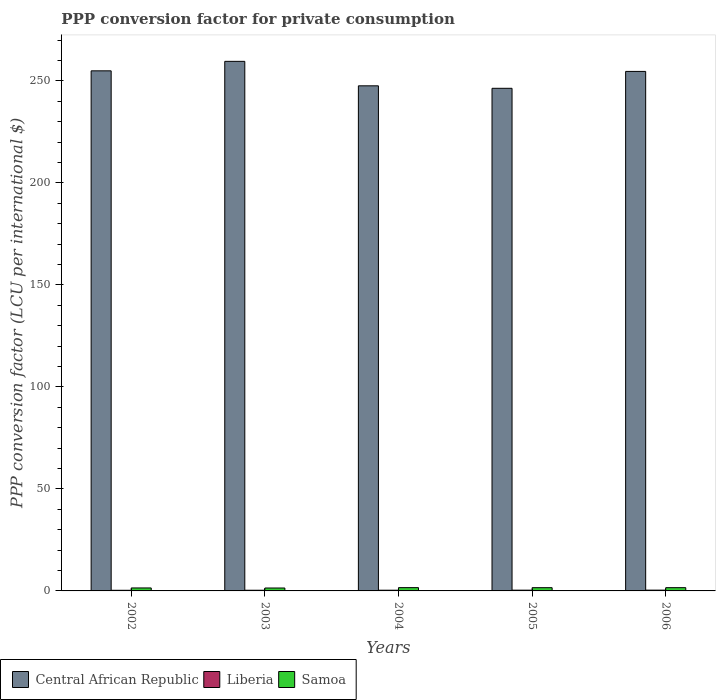How many different coloured bars are there?
Keep it short and to the point. 3. How many bars are there on the 1st tick from the right?
Give a very brief answer. 3. What is the label of the 1st group of bars from the left?
Your answer should be very brief. 2002. What is the PPP conversion factor for private consumption in Central African Republic in 2002?
Offer a terse response. 254.92. Across all years, what is the maximum PPP conversion factor for private consumption in Central African Republic?
Provide a succinct answer. 259.57. Across all years, what is the minimum PPP conversion factor for private consumption in Liberia?
Keep it short and to the point. 0.31. In which year was the PPP conversion factor for private consumption in Samoa maximum?
Your answer should be very brief. 2004. In which year was the PPP conversion factor for private consumption in Liberia minimum?
Offer a terse response. 2002. What is the total PPP conversion factor for private consumption in Liberia in the graph?
Offer a terse response. 1.74. What is the difference between the PPP conversion factor for private consumption in Central African Republic in 2002 and that in 2004?
Provide a short and direct response. 7.34. What is the difference between the PPP conversion factor for private consumption in Liberia in 2003 and the PPP conversion factor for private consumption in Samoa in 2005?
Ensure brevity in your answer.  -1.26. What is the average PPP conversion factor for private consumption in Central African Republic per year?
Give a very brief answer. 252.61. In the year 2006, what is the difference between the PPP conversion factor for private consumption in Central African Republic and PPP conversion factor for private consumption in Liberia?
Your answer should be compact. 254.25. What is the ratio of the PPP conversion factor for private consumption in Central African Republic in 2003 to that in 2004?
Ensure brevity in your answer.  1.05. What is the difference between the highest and the second highest PPP conversion factor for private consumption in Central African Republic?
Your answer should be very brief. 4.65. What is the difference between the highest and the lowest PPP conversion factor for private consumption in Liberia?
Give a very brief answer. 0.08. In how many years, is the PPP conversion factor for private consumption in Central African Republic greater than the average PPP conversion factor for private consumption in Central African Republic taken over all years?
Provide a succinct answer. 3. Is the sum of the PPP conversion factor for private consumption in Central African Republic in 2003 and 2004 greater than the maximum PPP conversion factor for private consumption in Samoa across all years?
Offer a terse response. Yes. What does the 1st bar from the left in 2004 represents?
Provide a succinct answer. Central African Republic. What does the 1st bar from the right in 2005 represents?
Keep it short and to the point. Samoa. Is it the case that in every year, the sum of the PPP conversion factor for private consumption in Samoa and PPP conversion factor for private consumption in Central African Republic is greater than the PPP conversion factor for private consumption in Liberia?
Your response must be concise. Yes. How many years are there in the graph?
Your answer should be very brief. 5. What is the difference between two consecutive major ticks on the Y-axis?
Your answer should be compact. 50. Are the values on the major ticks of Y-axis written in scientific E-notation?
Keep it short and to the point. No. Does the graph contain any zero values?
Offer a very short reply. No. Does the graph contain grids?
Give a very brief answer. No. Where does the legend appear in the graph?
Give a very brief answer. Bottom left. What is the title of the graph?
Provide a short and direct response. PPP conversion factor for private consumption. What is the label or title of the Y-axis?
Offer a terse response. PPP conversion factor (LCU per international $). What is the PPP conversion factor (LCU per international $) in Central African Republic in 2002?
Your answer should be compact. 254.92. What is the PPP conversion factor (LCU per international $) of Liberia in 2002?
Your answer should be compact. 0.31. What is the PPP conversion factor (LCU per international $) of Samoa in 2002?
Ensure brevity in your answer.  1.46. What is the PPP conversion factor (LCU per international $) in Central African Republic in 2003?
Ensure brevity in your answer.  259.57. What is the PPP conversion factor (LCU per international $) in Liberia in 2003?
Your response must be concise. 0.33. What is the PPP conversion factor (LCU per international $) of Samoa in 2003?
Keep it short and to the point. 1.42. What is the PPP conversion factor (LCU per international $) in Central African Republic in 2004?
Ensure brevity in your answer.  247.57. What is the PPP conversion factor (LCU per international $) of Liberia in 2004?
Your answer should be very brief. 0.35. What is the PPP conversion factor (LCU per international $) of Samoa in 2004?
Provide a succinct answer. 1.61. What is the PPP conversion factor (LCU per international $) of Central African Republic in 2005?
Keep it short and to the point. 246.35. What is the PPP conversion factor (LCU per international $) of Liberia in 2005?
Offer a terse response. 0.37. What is the PPP conversion factor (LCU per international $) of Samoa in 2005?
Provide a succinct answer. 1.59. What is the PPP conversion factor (LCU per international $) of Central African Republic in 2006?
Your answer should be very brief. 254.63. What is the PPP conversion factor (LCU per international $) of Liberia in 2006?
Your answer should be very brief. 0.39. What is the PPP conversion factor (LCU per international $) of Samoa in 2006?
Offer a very short reply. 1.6. Across all years, what is the maximum PPP conversion factor (LCU per international $) in Central African Republic?
Your response must be concise. 259.57. Across all years, what is the maximum PPP conversion factor (LCU per international $) of Liberia?
Offer a very short reply. 0.39. Across all years, what is the maximum PPP conversion factor (LCU per international $) of Samoa?
Ensure brevity in your answer.  1.61. Across all years, what is the minimum PPP conversion factor (LCU per international $) in Central African Republic?
Make the answer very short. 246.35. Across all years, what is the minimum PPP conversion factor (LCU per international $) of Liberia?
Offer a terse response. 0.31. Across all years, what is the minimum PPP conversion factor (LCU per international $) in Samoa?
Give a very brief answer. 1.42. What is the total PPP conversion factor (LCU per international $) of Central African Republic in the graph?
Provide a succinct answer. 1263.05. What is the total PPP conversion factor (LCU per international $) of Liberia in the graph?
Provide a succinct answer. 1.74. What is the total PPP conversion factor (LCU per international $) of Samoa in the graph?
Make the answer very short. 7.68. What is the difference between the PPP conversion factor (LCU per international $) of Central African Republic in 2002 and that in 2003?
Offer a terse response. -4.65. What is the difference between the PPP conversion factor (LCU per international $) in Liberia in 2002 and that in 2003?
Your answer should be compact. -0.02. What is the difference between the PPP conversion factor (LCU per international $) in Samoa in 2002 and that in 2003?
Provide a short and direct response. 0.03. What is the difference between the PPP conversion factor (LCU per international $) of Central African Republic in 2002 and that in 2004?
Your answer should be very brief. 7.34. What is the difference between the PPP conversion factor (LCU per international $) of Liberia in 2002 and that in 2004?
Make the answer very short. -0.04. What is the difference between the PPP conversion factor (LCU per international $) in Samoa in 2002 and that in 2004?
Your answer should be compact. -0.16. What is the difference between the PPP conversion factor (LCU per international $) of Central African Republic in 2002 and that in 2005?
Give a very brief answer. 8.56. What is the difference between the PPP conversion factor (LCU per international $) of Liberia in 2002 and that in 2005?
Your answer should be very brief. -0.07. What is the difference between the PPP conversion factor (LCU per international $) in Samoa in 2002 and that in 2005?
Your answer should be compact. -0.13. What is the difference between the PPP conversion factor (LCU per international $) in Central African Republic in 2002 and that in 2006?
Provide a succinct answer. 0.28. What is the difference between the PPP conversion factor (LCU per international $) of Liberia in 2002 and that in 2006?
Provide a succinct answer. -0.08. What is the difference between the PPP conversion factor (LCU per international $) of Samoa in 2002 and that in 2006?
Make the answer very short. -0.14. What is the difference between the PPP conversion factor (LCU per international $) in Central African Republic in 2003 and that in 2004?
Your answer should be compact. 11.99. What is the difference between the PPP conversion factor (LCU per international $) of Liberia in 2003 and that in 2004?
Keep it short and to the point. -0.02. What is the difference between the PPP conversion factor (LCU per international $) in Samoa in 2003 and that in 2004?
Your answer should be very brief. -0.19. What is the difference between the PPP conversion factor (LCU per international $) in Central African Republic in 2003 and that in 2005?
Your answer should be compact. 13.21. What is the difference between the PPP conversion factor (LCU per international $) of Liberia in 2003 and that in 2005?
Make the answer very short. -0.04. What is the difference between the PPP conversion factor (LCU per international $) in Samoa in 2003 and that in 2005?
Keep it short and to the point. -0.17. What is the difference between the PPP conversion factor (LCU per international $) in Central African Republic in 2003 and that in 2006?
Your answer should be very brief. 4.93. What is the difference between the PPP conversion factor (LCU per international $) of Liberia in 2003 and that in 2006?
Offer a very short reply. -0.06. What is the difference between the PPP conversion factor (LCU per international $) in Samoa in 2003 and that in 2006?
Make the answer very short. -0.17. What is the difference between the PPP conversion factor (LCU per international $) in Central African Republic in 2004 and that in 2005?
Ensure brevity in your answer.  1.22. What is the difference between the PPP conversion factor (LCU per international $) of Liberia in 2004 and that in 2005?
Ensure brevity in your answer.  -0.03. What is the difference between the PPP conversion factor (LCU per international $) in Samoa in 2004 and that in 2005?
Your answer should be compact. 0.02. What is the difference between the PPP conversion factor (LCU per international $) in Central African Republic in 2004 and that in 2006?
Ensure brevity in your answer.  -7.06. What is the difference between the PPP conversion factor (LCU per international $) of Liberia in 2004 and that in 2006?
Your answer should be very brief. -0.04. What is the difference between the PPP conversion factor (LCU per international $) in Samoa in 2004 and that in 2006?
Your answer should be compact. 0.02. What is the difference between the PPP conversion factor (LCU per international $) of Central African Republic in 2005 and that in 2006?
Provide a succinct answer. -8.28. What is the difference between the PPP conversion factor (LCU per international $) of Liberia in 2005 and that in 2006?
Provide a short and direct response. -0.01. What is the difference between the PPP conversion factor (LCU per international $) in Samoa in 2005 and that in 2006?
Give a very brief answer. -0.01. What is the difference between the PPP conversion factor (LCU per international $) of Central African Republic in 2002 and the PPP conversion factor (LCU per international $) of Liberia in 2003?
Offer a very short reply. 254.59. What is the difference between the PPP conversion factor (LCU per international $) of Central African Republic in 2002 and the PPP conversion factor (LCU per international $) of Samoa in 2003?
Your answer should be very brief. 253.49. What is the difference between the PPP conversion factor (LCU per international $) of Liberia in 2002 and the PPP conversion factor (LCU per international $) of Samoa in 2003?
Give a very brief answer. -1.12. What is the difference between the PPP conversion factor (LCU per international $) in Central African Republic in 2002 and the PPP conversion factor (LCU per international $) in Liberia in 2004?
Your answer should be compact. 254.57. What is the difference between the PPP conversion factor (LCU per international $) of Central African Republic in 2002 and the PPP conversion factor (LCU per international $) of Samoa in 2004?
Give a very brief answer. 253.3. What is the difference between the PPP conversion factor (LCU per international $) of Liberia in 2002 and the PPP conversion factor (LCU per international $) of Samoa in 2004?
Offer a terse response. -1.31. What is the difference between the PPP conversion factor (LCU per international $) in Central African Republic in 2002 and the PPP conversion factor (LCU per international $) in Liberia in 2005?
Keep it short and to the point. 254.55. What is the difference between the PPP conversion factor (LCU per international $) in Central African Republic in 2002 and the PPP conversion factor (LCU per international $) in Samoa in 2005?
Offer a very short reply. 253.33. What is the difference between the PPP conversion factor (LCU per international $) in Liberia in 2002 and the PPP conversion factor (LCU per international $) in Samoa in 2005?
Give a very brief answer. -1.28. What is the difference between the PPP conversion factor (LCU per international $) in Central African Republic in 2002 and the PPP conversion factor (LCU per international $) in Liberia in 2006?
Your response must be concise. 254.53. What is the difference between the PPP conversion factor (LCU per international $) in Central African Republic in 2002 and the PPP conversion factor (LCU per international $) in Samoa in 2006?
Provide a short and direct response. 253.32. What is the difference between the PPP conversion factor (LCU per international $) in Liberia in 2002 and the PPP conversion factor (LCU per international $) in Samoa in 2006?
Make the answer very short. -1.29. What is the difference between the PPP conversion factor (LCU per international $) in Central African Republic in 2003 and the PPP conversion factor (LCU per international $) in Liberia in 2004?
Keep it short and to the point. 259.22. What is the difference between the PPP conversion factor (LCU per international $) in Central African Republic in 2003 and the PPP conversion factor (LCU per international $) in Samoa in 2004?
Give a very brief answer. 257.95. What is the difference between the PPP conversion factor (LCU per international $) in Liberia in 2003 and the PPP conversion factor (LCU per international $) in Samoa in 2004?
Your answer should be compact. -1.28. What is the difference between the PPP conversion factor (LCU per international $) in Central African Republic in 2003 and the PPP conversion factor (LCU per international $) in Liberia in 2005?
Your answer should be compact. 259.19. What is the difference between the PPP conversion factor (LCU per international $) of Central African Republic in 2003 and the PPP conversion factor (LCU per international $) of Samoa in 2005?
Offer a very short reply. 257.98. What is the difference between the PPP conversion factor (LCU per international $) in Liberia in 2003 and the PPP conversion factor (LCU per international $) in Samoa in 2005?
Your answer should be compact. -1.26. What is the difference between the PPP conversion factor (LCU per international $) of Central African Republic in 2003 and the PPP conversion factor (LCU per international $) of Liberia in 2006?
Ensure brevity in your answer.  259.18. What is the difference between the PPP conversion factor (LCU per international $) in Central African Republic in 2003 and the PPP conversion factor (LCU per international $) in Samoa in 2006?
Offer a terse response. 257.97. What is the difference between the PPP conversion factor (LCU per international $) of Liberia in 2003 and the PPP conversion factor (LCU per international $) of Samoa in 2006?
Your response must be concise. -1.27. What is the difference between the PPP conversion factor (LCU per international $) of Central African Republic in 2004 and the PPP conversion factor (LCU per international $) of Liberia in 2005?
Provide a succinct answer. 247.2. What is the difference between the PPP conversion factor (LCU per international $) in Central African Republic in 2004 and the PPP conversion factor (LCU per international $) in Samoa in 2005?
Provide a short and direct response. 245.98. What is the difference between the PPP conversion factor (LCU per international $) in Liberia in 2004 and the PPP conversion factor (LCU per international $) in Samoa in 2005?
Keep it short and to the point. -1.24. What is the difference between the PPP conversion factor (LCU per international $) of Central African Republic in 2004 and the PPP conversion factor (LCU per international $) of Liberia in 2006?
Your answer should be very brief. 247.19. What is the difference between the PPP conversion factor (LCU per international $) of Central African Republic in 2004 and the PPP conversion factor (LCU per international $) of Samoa in 2006?
Keep it short and to the point. 245.98. What is the difference between the PPP conversion factor (LCU per international $) of Liberia in 2004 and the PPP conversion factor (LCU per international $) of Samoa in 2006?
Give a very brief answer. -1.25. What is the difference between the PPP conversion factor (LCU per international $) in Central African Republic in 2005 and the PPP conversion factor (LCU per international $) in Liberia in 2006?
Give a very brief answer. 245.97. What is the difference between the PPP conversion factor (LCU per international $) in Central African Republic in 2005 and the PPP conversion factor (LCU per international $) in Samoa in 2006?
Keep it short and to the point. 244.76. What is the difference between the PPP conversion factor (LCU per international $) of Liberia in 2005 and the PPP conversion factor (LCU per international $) of Samoa in 2006?
Offer a very short reply. -1.22. What is the average PPP conversion factor (LCU per international $) in Central African Republic per year?
Give a very brief answer. 252.61. What is the average PPP conversion factor (LCU per international $) in Liberia per year?
Offer a very short reply. 0.35. What is the average PPP conversion factor (LCU per international $) in Samoa per year?
Offer a terse response. 1.54. In the year 2002, what is the difference between the PPP conversion factor (LCU per international $) in Central African Republic and PPP conversion factor (LCU per international $) in Liberia?
Your answer should be very brief. 254.61. In the year 2002, what is the difference between the PPP conversion factor (LCU per international $) in Central African Republic and PPP conversion factor (LCU per international $) in Samoa?
Give a very brief answer. 253.46. In the year 2002, what is the difference between the PPP conversion factor (LCU per international $) in Liberia and PPP conversion factor (LCU per international $) in Samoa?
Ensure brevity in your answer.  -1.15. In the year 2003, what is the difference between the PPP conversion factor (LCU per international $) in Central African Republic and PPP conversion factor (LCU per international $) in Liberia?
Provide a short and direct response. 259.24. In the year 2003, what is the difference between the PPP conversion factor (LCU per international $) in Central African Republic and PPP conversion factor (LCU per international $) in Samoa?
Make the answer very short. 258.14. In the year 2003, what is the difference between the PPP conversion factor (LCU per international $) in Liberia and PPP conversion factor (LCU per international $) in Samoa?
Your response must be concise. -1.09. In the year 2004, what is the difference between the PPP conversion factor (LCU per international $) in Central African Republic and PPP conversion factor (LCU per international $) in Liberia?
Give a very brief answer. 247.23. In the year 2004, what is the difference between the PPP conversion factor (LCU per international $) of Central African Republic and PPP conversion factor (LCU per international $) of Samoa?
Make the answer very short. 245.96. In the year 2004, what is the difference between the PPP conversion factor (LCU per international $) of Liberia and PPP conversion factor (LCU per international $) of Samoa?
Ensure brevity in your answer.  -1.27. In the year 2005, what is the difference between the PPP conversion factor (LCU per international $) of Central African Republic and PPP conversion factor (LCU per international $) of Liberia?
Your answer should be very brief. 245.98. In the year 2005, what is the difference between the PPP conversion factor (LCU per international $) of Central African Republic and PPP conversion factor (LCU per international $) of Samoa?
Your response must be concise. 244.77. In the year 2005, what is the difference between the PPP conversion factor (LCU per international $) of Liberia and PPP conversion factor (LCU per international $) of Samoa?
Ensure brevity in your answer.  -1.22. In the year 2006, what is the difference between the PPP conversion factor (LCU per international $) in Central African Republic and PPP conversion factor (LCU per international $) in Liberia?
Your answer should be compact. 254.25. In the year 2006, what is the difference between the PPP conversion factor (LCU per international $) in Central African Republic and PPP conversion factor (LCU per international $) in Samoa?
Your answer should be very brief. 253.04. In the year 2006, what is the difference between the PPP conversion factor (LCU per international $) in Liberia and PPP conversion factor (LCU per international $) in Samoa?
Give a very brief answer. -1.21. What is the ratio of the PPP conversion factor (LCU per international $) of Central African Republic in 2002 to that in 2003?
Keep it short and to the point. 0.98. What is the ratio of the PPP conversion factor (LCU per international $) in Liberia in 2002 to that in 2003?
Keep it short and to the point. 0.93. What is the ratio of the PPP conversion factor (LCU per international $) of Samoa in 2002 to that in 2003?
Provide a short and direct response. 1.02. What is the ratio of the PPP conversion factor (LCU per international $) in Central African Republic in 2002 to that in 2004?
Offer a terse response. 1.03. What is the ratio of the PPP conversion factor (LCU per international $) in Liberia in 2002 to that in 2004?
Make the answer very short. 0.88. What is the ratio of the PPP conversion factor (LCU per international $) of Samoa in 2002 to that in 2004?
Ensure brevity in your answer.  0.9. What is the ratio of the PPP conversion factor (LCU per international $) in Central African Republic in 2002 to that in 2005?
Your answer should be very brief. 1.03. What is the ratio of the PPP conversion factor (LCU per international $) of Liberia in 2002 to that in 2005?
Offer a very short reply. 0.82. What is the ratio of the PPP conversion factor (LCU per international $) of Samoa in 2002 to that in 2005?
Provide a short and direct response. 0.92. What is the ratio of the PPP conversion factor (LCU per international $) in Liberia in 2002 to that in 2006?
Keep it short and to the point. 0.79. What is the ratio of the PPP conversion factor (LCU per international $) in Samoa in 2002 to that in 2006?
Give a very brief answer. 0.91. What is the ratio of the PPP conversion factor (LCU per international $) in Central African Republic in 2003 to that in 2004?
Keep it short and to the point. 1.05. What is the ratio of the PPP conversion factor (LCU per international $) of Liberia in 2003 to that in 2004?
Provide a succinct answer. 0.95. What is the ratio of the PPP conversion factor (LCU per international $) of Samoa in 2003 to that in 2004?
Ensure brevity in your answer.  0.88. What is the ratio of the PPP conversion factor (LCU per international $) in Central African Republic in 2003 to that in 2005?
Provide a succinct answer. 1.05. What is the ratio of the PPP conversion factor (LCU per international $) in Liberia in 2003 to that in 2005?
Your response must be concise. 0.89. What is the ratio of the PPP conversion factor (LCU per international $) in Samoa in 2003 to that in 2005?
Your answer should be very brief. 0.9. What is the ratio of the PPP conversion factor (LCU per international $) in Central African Republic in 2003 to that in 2006?
Provide a succinct answer. 1.02. What is the ratio of the PPP conversion factor (LCU per international $) of Liberia in 2003 to that in 2006?
Your response must be concise. 0.85. What is the ratio of the PPP conversion factor (LCU per international $) in Samoa in 2003 to that in 2006?
Your answer should be compact. 0.89. What is the ratio of the PPP conversion factor (LCU per international $) of Liberia in 2004 to that in 2005?
Keep it short and to the point. 0.93. What is the ratio of the PPP conversion factor (LCU per international $) of Samoa in 2004 to that in 2005?
Make the answer very short. 1.02. What is the ratio of the PPP conversion factor (LCU per international $) of Central African Republic in 2004 to that in 2006?
Offer a very short reply. 0.97. What is the ratio of the PPP conversion factor (LCU per international $) of Liberia in 2004 to that in 2006?
Give a very brief answer. 0.9. What is the ratio of the PPP conversion factor (LCU per international $) in Samoa in 2004 to that in 2006?
Provide a succinct answer. 1.01. What is the ratio of the PPP conversion factor (LCU per international $) of Central African Republic in 2005 to that in 2006?
Give a very brief answer. 0.97. What is the ratio of the PPP conversion factor (LCU per international $) of Liberia in 2005 to that in 2006?
Provide a succinct answer. 0.96. What is the ratio of the PPP conversion factor (LCU per international $) in Samoa in 2005 to that in 2006?
Keep it short and to the point. 1. What is the difference between the highest and the second highest PPP conversion factor (LCU per international $) of Central African Republic?
Give a very brief answer. 4.65. What is the difference between the highest and the second highest PPP conversion factor (LCU per international $) of Liberia?
Your response must be concise. 0.01. What is the difference between the highest and the second highest PPP conversion factor (LCU per international $) of Samoa?
Give a very brief answer. 0.02. What is the difference between the highest and the lowest PPP conversion factor (LCU per international $) in Central African Republic?
Keep it short and to the point. 13.21. What is the difference between the highest and the lowest PPP conversion factor (LCU per international $) of Liberia?
Your response must be concise. 0.08. What is the difference between the highest and the lowest PPP conversion factor (LCU per international $) in Samoa?
Your answer should be compact. 0.19. 